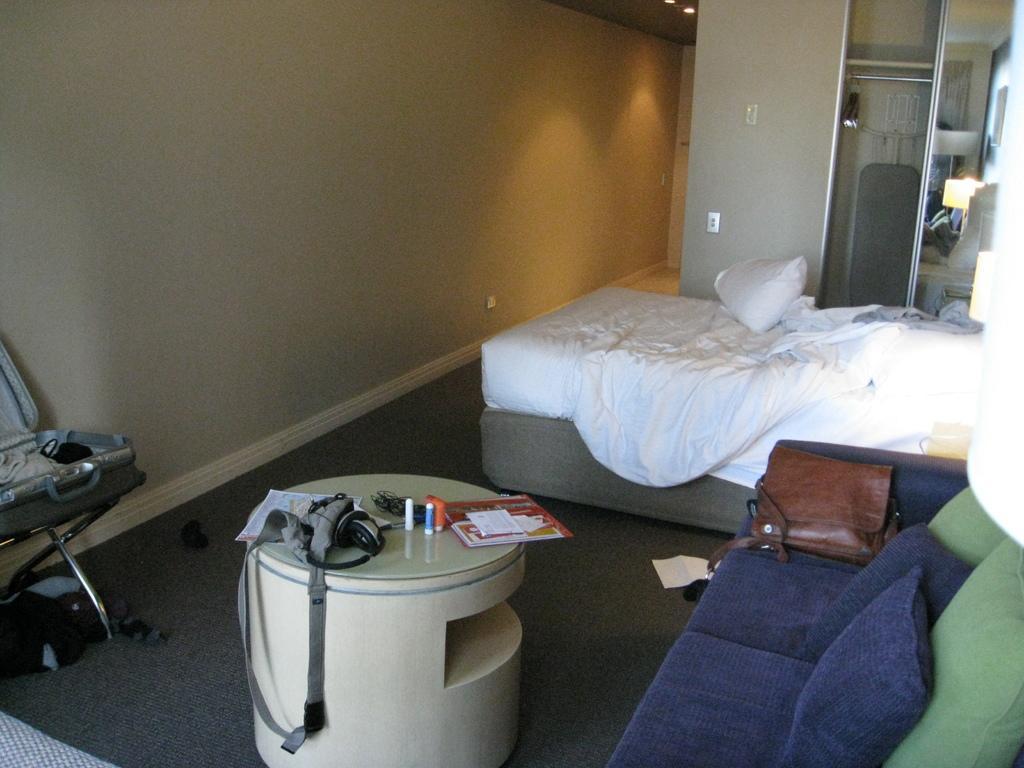Could you give a brief overview of what you see in this image? In this image I can see a table. on the table there is a paper,head set and some of the objects. To the right there is a couch and a bag on the couch. To the side of the couch there is a bed with white sheet. There is a pillow on that. To the left there is a chair and at the back there is a wall 